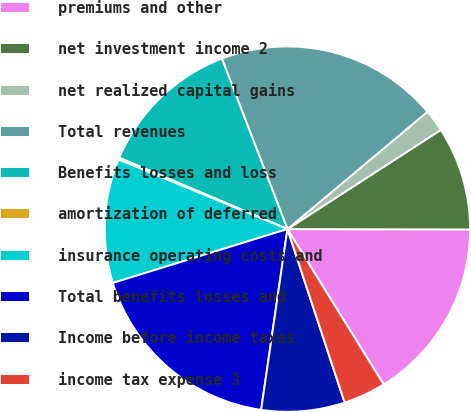Convert chart to OTSL. <chart><loc_0><loc_0><loc_500><loc_500><pie_chart><fcel>premiums and other<fcel>net investment income 2<fcel>net realized capital gains<fcel>Total revenues<fcel>Benefits losses and loss<fcel>amortization of deferred<fcel>insurance operating costs and<fcel>Total benefits losses and<fcel>Income before income taxes<fcel>income tax expense 3<nl><fcel>16.14%<fcel>9.17%<fcel>1.96%<fcel>19.74%<fcel>12.78%<fcel>0.16%<fcel>10.98%<fcel>17.94%<fcel>7.37%<fcel>3.76%<nl></chart> 